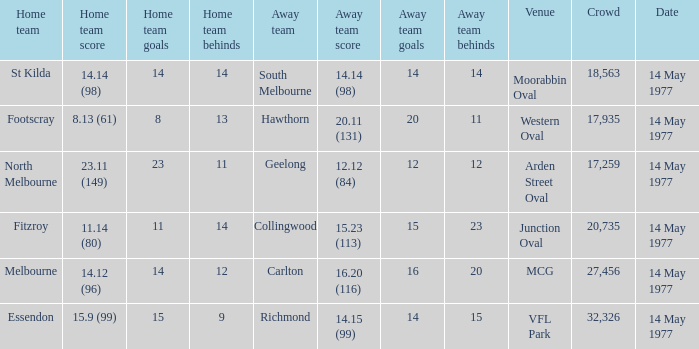Parse the table in full. {'header': ['Home team', 'Home team score', 'Home team goals', 'Home team behinds', 'Away team', 'Away team score', 'Away team goals', 'Away team behinds', 'Venue', 'Crowd', 'Date'], 'rows': [['St Kilda', '14.14 (98)', '14', '14', 'South Melbourne', '14.14 (98)', '14', '14', 'Moorabbin Oval', '18,563', '14 May 1977'], ['Footscray', '8.13 (61)', '8', '13', 'Hawthorn', '20.11 (131)', '20', '11', 'Western Oval', '17,935', '14 May 1977'], ['North Melbourne', '23.11 (149)', '23', '11', 'Geelong', '12.12 (84)', '12', '12', 'Arden Street Oval', '17,259', '14 May 1977'], ['Fitzroy', '11.14 (80)', '11', '14', 'Collingwood', '15.23 (113)', '15', '23', 'Junction Oval', '20,735', '14 May 1977'], ['Melbourne', '14.12 (96)', '14', '12', 'Carlton', '16.20 (116)', '16', '20', 'MCG', '27,456', '14 May 1977'], ['Essendon', '15.9 (99)', '15', '9', 'Richmond', '14.15 (99)', '14', '15', 'VFL Park', '32,326', '14 May 1977']]} I want to know the home team score of the away team of richmond that has a crowd more than 20,735 15.9 (99). 